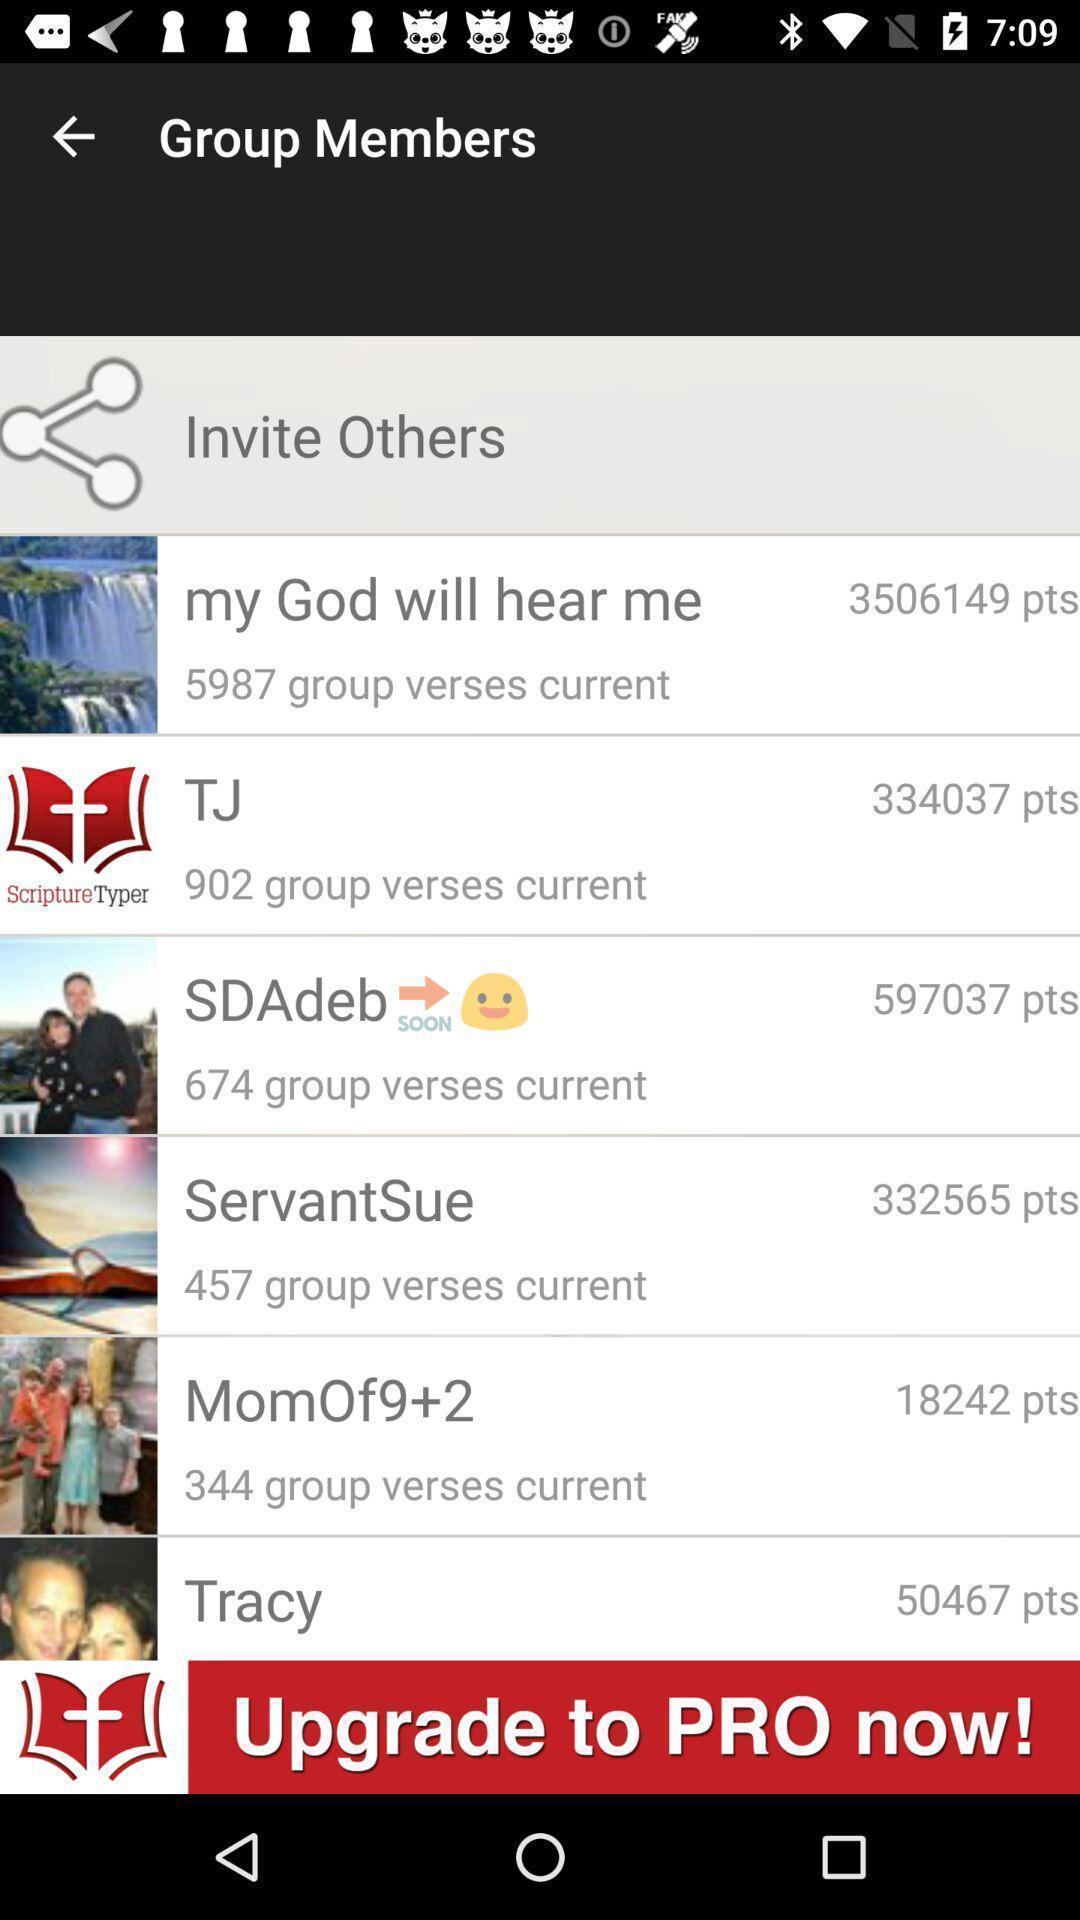Tell me about the visual elements in this screen capture. Screen displaying multiple users profile information. 